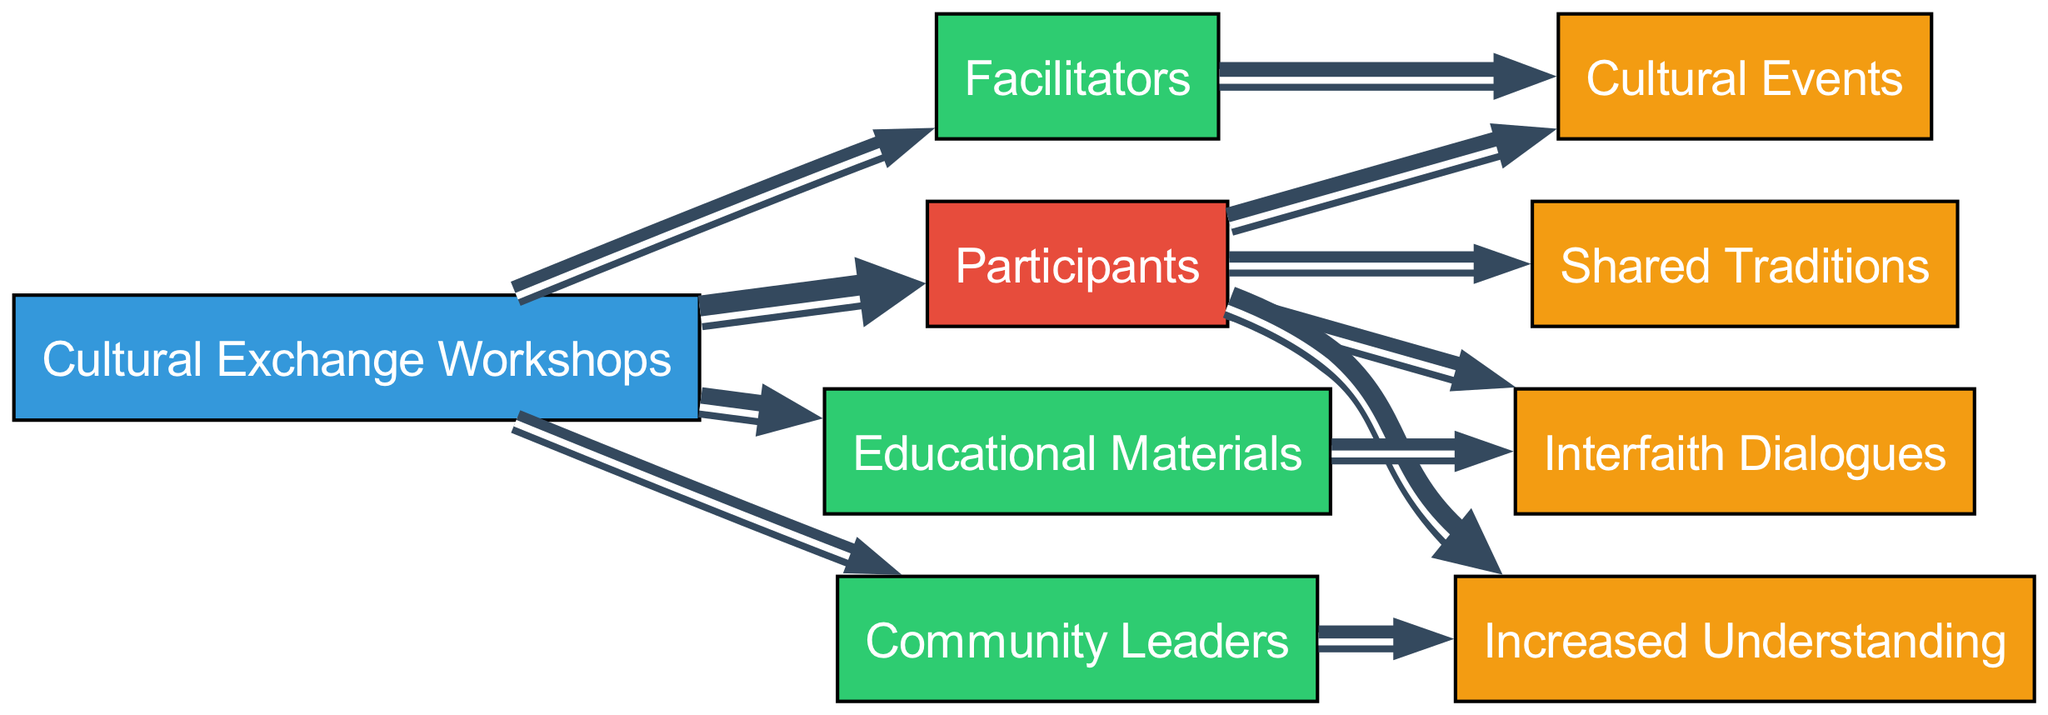What is the total number of participants in the workshops? The diagram shows a direct link from "Cultural Exchange Workshops" to "Participants" with a value of 200. Therefore, the total number of participants is the value indicated on this link.
Answer: 200 Which resource has the highest value linked to the workshops? Looking at the links emanating from "Cultural Exchange Workshops," the resources are "Educational Materials" with a value of 150, "Facilitators" with a value of 100, and "Community Leaders" with a value of 80. The highest value among these is from "Educational Materials."
Answer: Educational Materials What is the total number of outcomes generated by the participants? The diagram lists the outcomes linked to "Participants" as "Cultural Events," "Interfaith Dialogues," "Increased Understanding," and "Shared Traditions" with respective values of 130, 120, 180, and 90. Adding these together gives a total of 620.
Answer: 620 Which outcome has the highest connection from participants? The values linked to "Participants" are 130 for "Cultural Events," 120 for "Interfaith Dialogues," 180 for "Increased Understanding," and 90 for "Shared Traditions." The highest value is from "Increased Understanding."
Answer: Increased Understanding How many community leaders are involved in the workshops? The diagram shows a link from "Cultural Exchange Workshops" to "Community Leaders" with a value of 80. This indicates that 80 community leaders are involved in the workshops.
Answer: 80 What resource contributes the most to interfaith dialogues? There are two links leading to "Interfaith Dialogues": 120 from "Participants" and 100 from "Educational Materials." The larger contributor is from "Participants" with a value of 120.
Answer: Participants What is the combined value of all resources? The resources are "Educational Materials" (150), "Facilitators" (100), and "Community Leaders" (80). Adding these values totals to 330.
Answer: 330 Which node has two outgoing links with the same value? "Facilitators" has outgoing links to "Cultural Events" (130) and "Participants" (100), but the only node with two links of the same value is "Participants" to both "Cultural Events" (130) and "Interfaith Dialogues" (120). However, those values are different; thus, no node matches this condition.
Answer: None What percentage of participants contributed to increased understanding? The value linked from "Participants" to "Increased Understanding" is 180 out of 200 participants, so (180/200) * 100 gives 90%.
Answer: 90% 